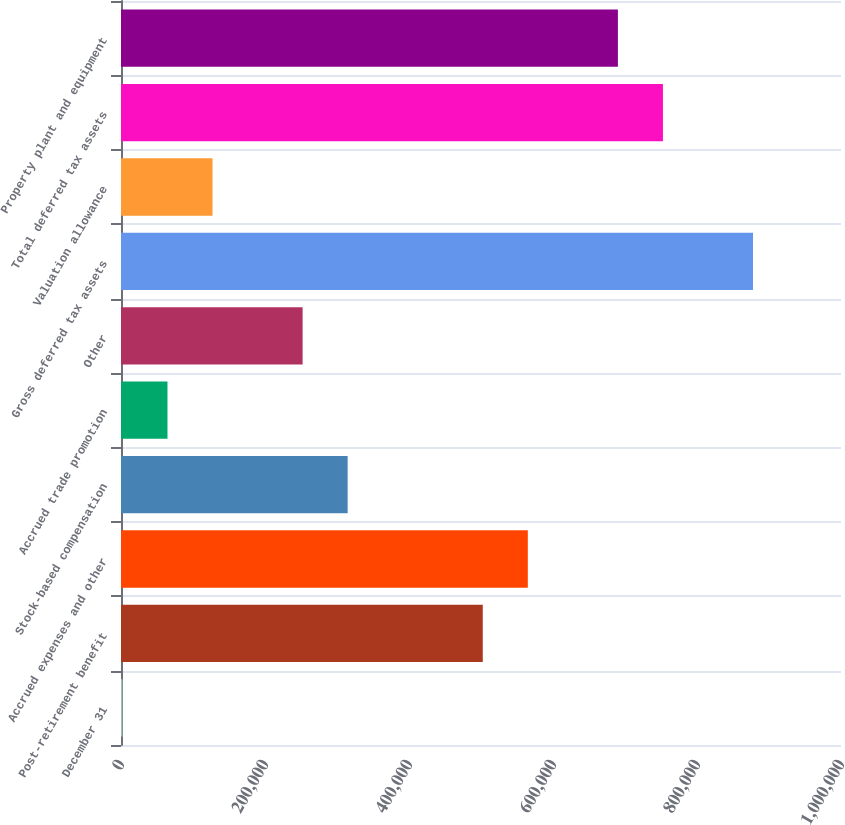Convert chart to OTSL. <chart><loc_0><loc_0><loc_500><loc_500><bar_chart><fcel>December 31<fcel>Post-retirement benefit<fcel>Accrued expenses and other<fcel>Stock-based compensation<fcel>Accrued trade promotion<fcel>Other<fcel>Gross deferred tax assets<fcel>Valuation allowance<fcel>Total deferred tax assets<fcel>Property plant and equipment<nl><fcel>2005<fcel>502466<fcel>565023<fcel>314793<fcel>64562.6<fcel>252235<fcel>877811<fcel>127120<fcel>752696<fcel>690139<nl></chart> 